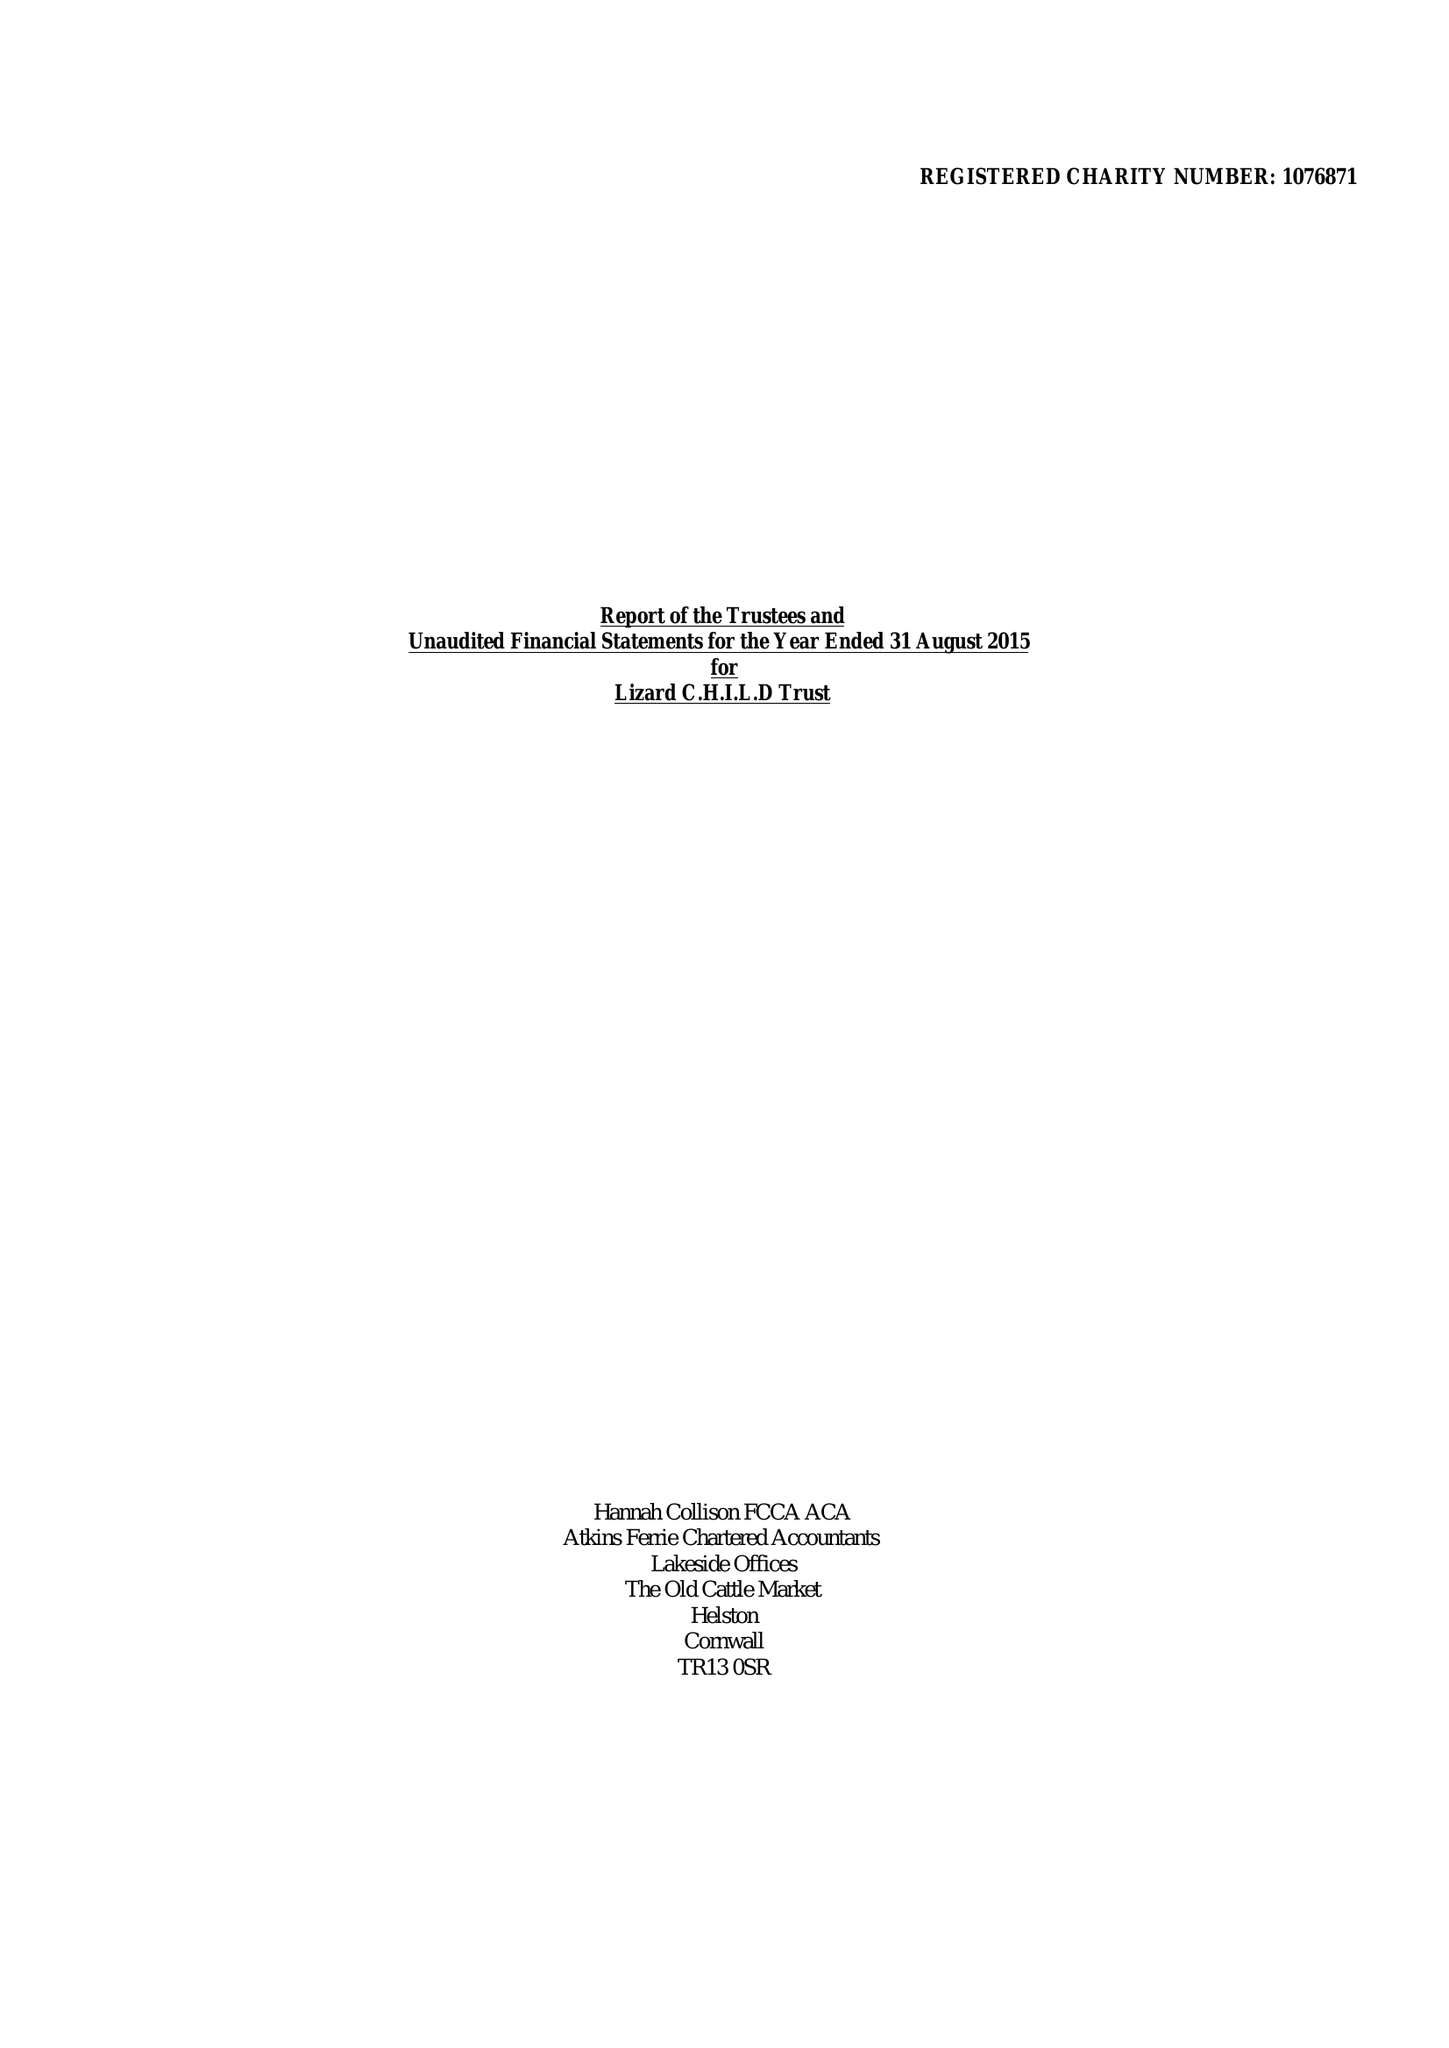What is the value for the spending_annually_in_british_pounds?
Answer the question using a single word or phrase. 253050.00 